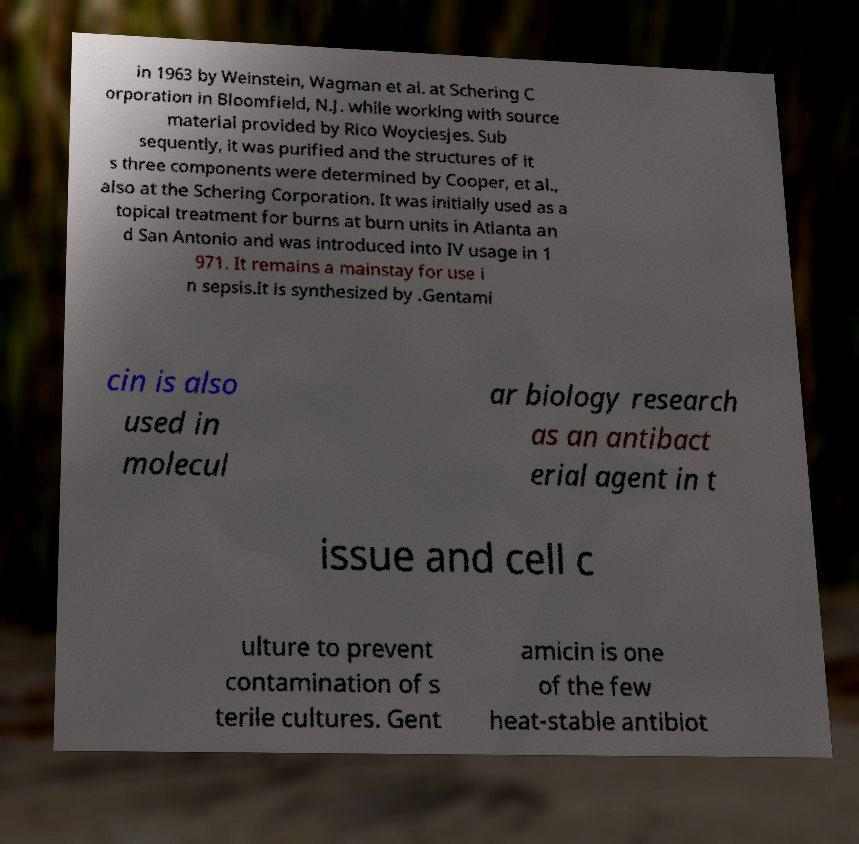There's text embedded in this image that I need extracted. Can you transcribe it verbatim? in 1963 by Weinstein, Wagman et al. at Schering C orporation in Bloomfield, N.J. while working with source material provided by Rico Woyciesjes. Sub sequently, it was purified and the structures of it s three components were determined by Cooper, et al., also at the Schering Corporation. It was initially used as a topical treatment for burns at burn units in Atlanta an d San Antonio and was introduced into IV usage in 1 971. It remains a mainstay for use i n sepsis.It is synthesized by .Gentami cin is also used in molecul ar biology research as an antibact erial agent in t issue and cell c ulture to prevent contamination of s terile cultures. Gent amicin is one of the few heat-stable antibiot 